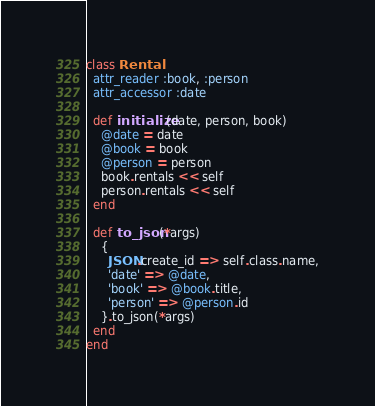<code> <loc_0><loc_0><loc_500><loc_500><_Ruby_>class Rental
  attr_reader :book, :person
  attr_accessor :date

  def initialize(date, person, book)
    @date = date
    @book = book
    @person = person
    book.rentals << self
    person.rentals << self
  end

  def to_json(*args)
    {
      JSON.create_id => self.class.name,
      'date' => @date,
      'book' => @book.title,
      'person' => @person.id
    }.to_json(*args)
  end
end
</code> 